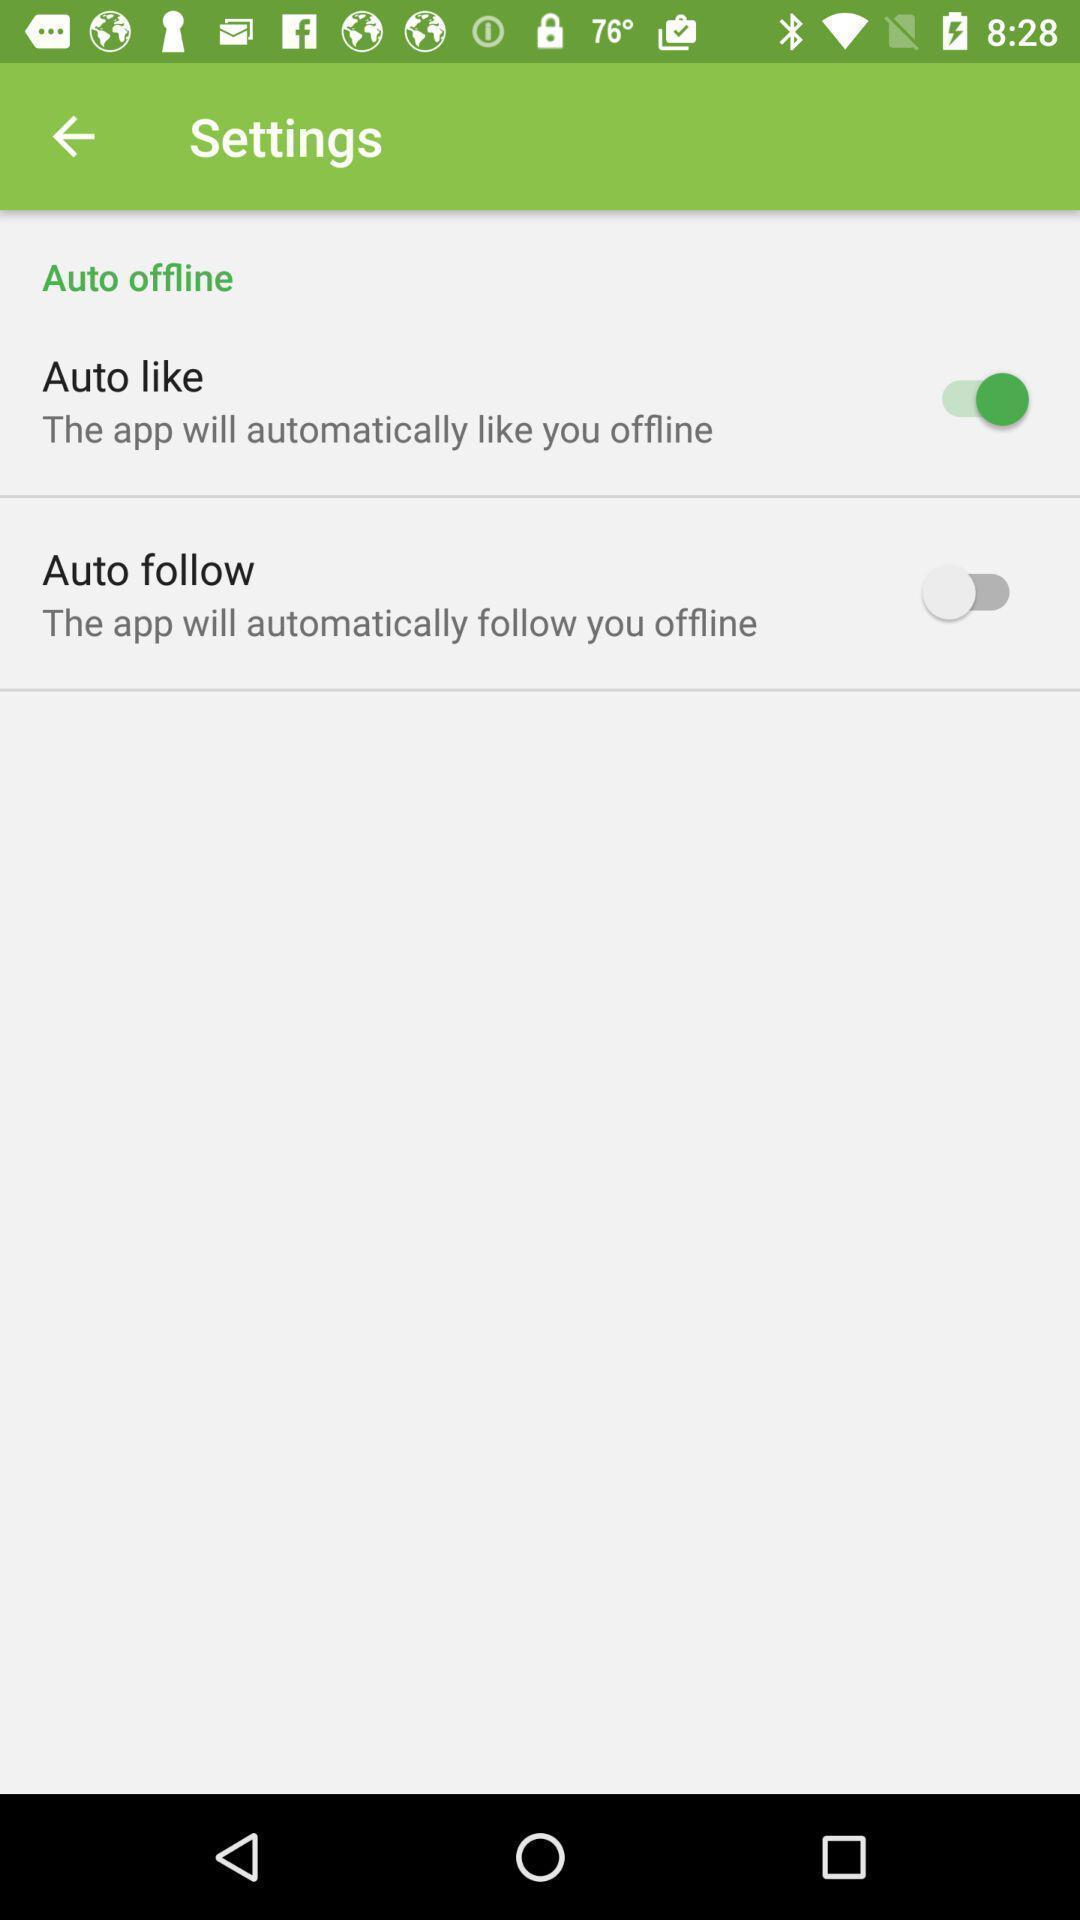Tell me about the visual elements in this screen capture. Settings page with auto offline on-off bar. 